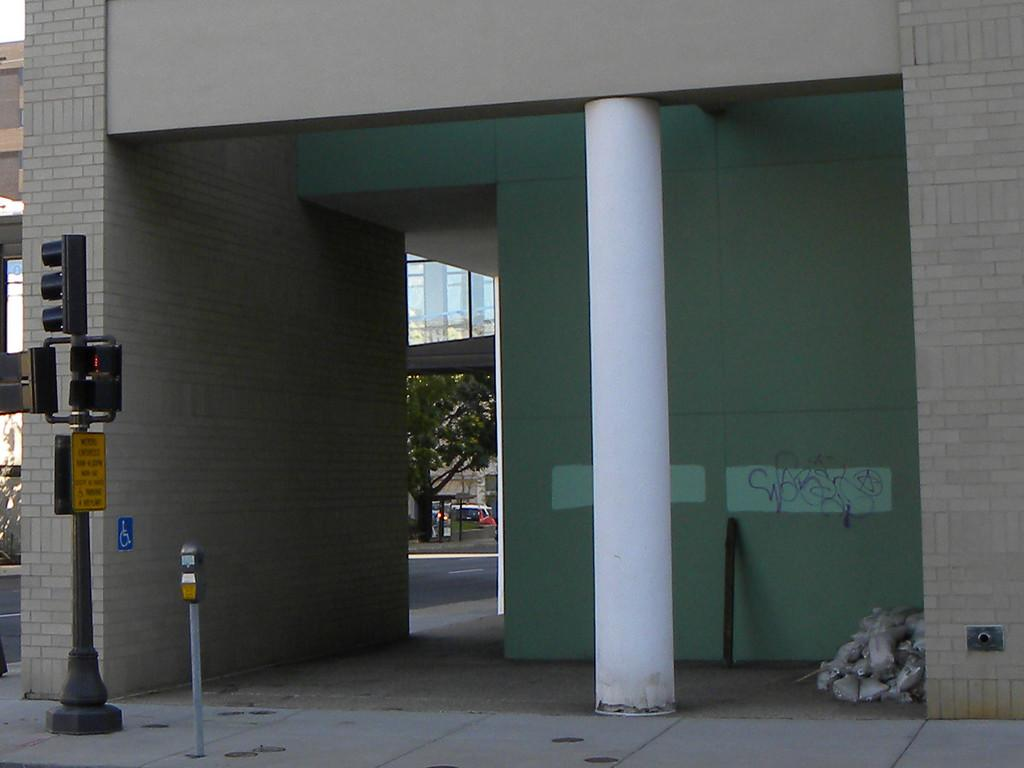What type of structure can be seen in the image? There is a building in the image. What architectural element is present in the image? There is a wall in the image. What supports the structure in the image? There is a pillar in the image. What is used to regulate traffic in the image? There is a pole with traffic lights in the image. What type of vegetation is present in the image? There is a tree in the image. How many cats are sitting on the traffic lights in the image? There are no cats present in the image. What type of fruit is hanging from the tree in the image? There is no fruit, including bananas, hanging from the tree in the image. 